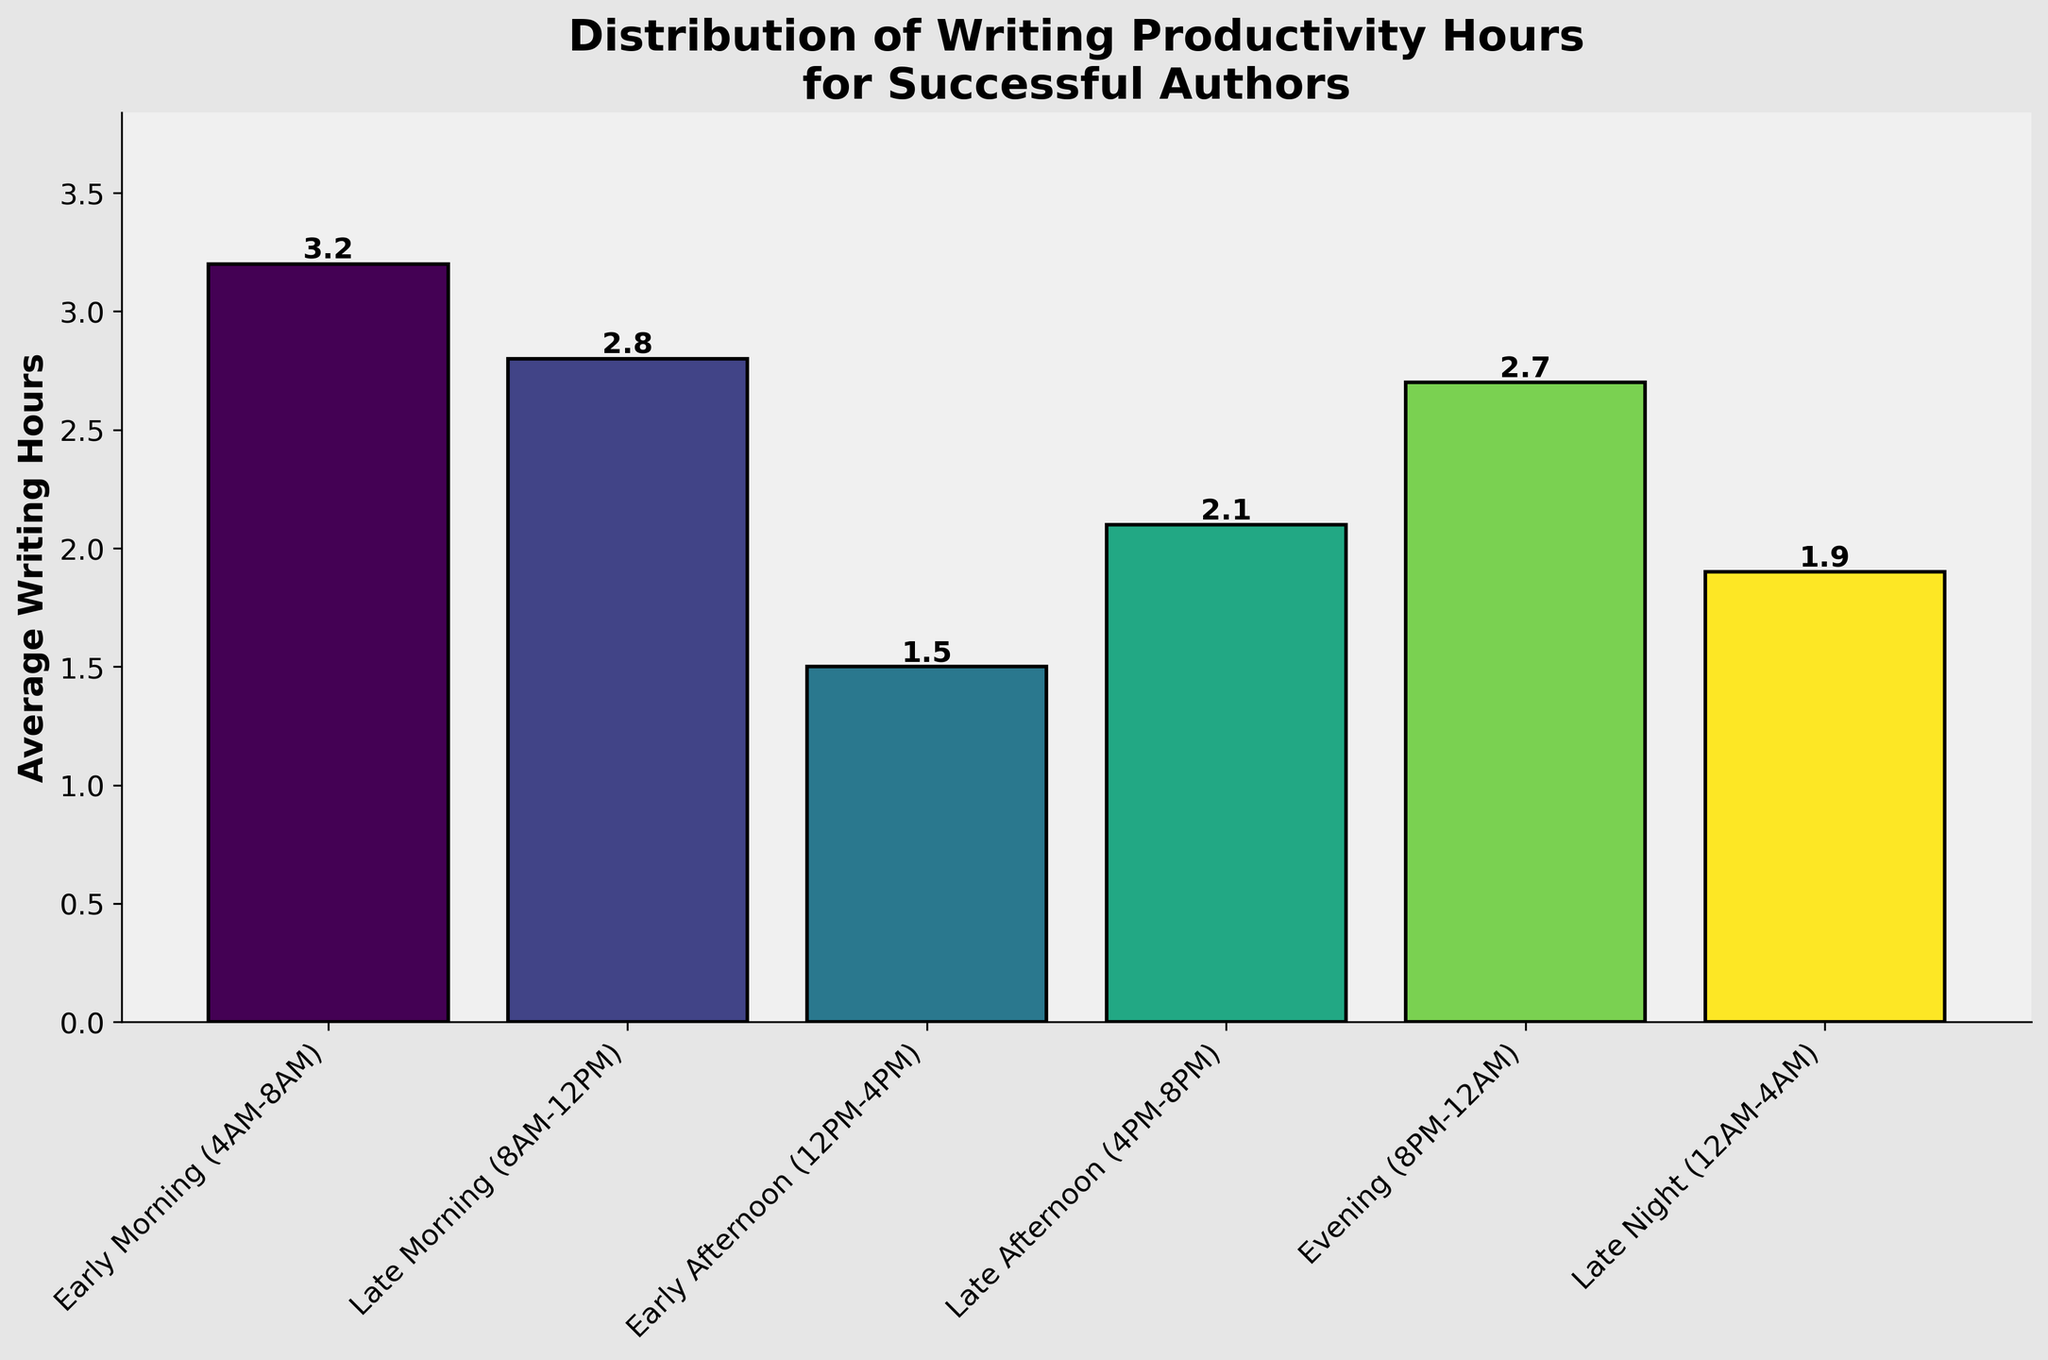What time of day has the highest average writing hours? The highest bar visually represents the time with the highest average writing hours. By looking at the plot, Early Morning (4AM-8AM) has the tallest bar, indicating the highest average.
Answer: Early Morning (4AM-8AM) Which time of day has a smaller average writing hours: Late Morning or Evening? By comparing the heights of the bars for Late Morning (8AM-12PM) and Evening (8PM-12AM), Late Morning has 2.8 hours, and Evening has 2.7 hours. Late Morning has a slightly larger average.
Answer: Evening (8PM-12AM) What is the total average writing hours for authors from Early Afternoon to Late Night combined? Sum the average writing hours of the periods from Early Afternoon (12PM-4PM), Late Afternoon (4PM-8PM), Evening (8PM-12AM), and Late Night (12AM-4AM). The totals are: 1.5 + 2.1 + 2.7 + 1.9 = 8.2 hours.
Answer: 8.2 If you only considered writing hours from 4AM to 8PM, what would be the average of those hours? Sum the hours for Early Morning (4AM-8AM), Late Morning (8AM-12PM), Early Afternoon (12PM-4PM), and Late Afternoon (4PM-8PM), then divide by the number of periods. The calculation is: (3.2 + 2.8 + 1.5 + 2.1) / 4 = 2.4 average hours.
Answer: 2.4 What is the difference in average writing hours between Early Morning and Early Afternoon? Subtract the average writing hours of Early Afternoon (1.5) from Early Morning (3.2). The difference is 3.2 - 1.5 = 1.7 hours.
Answer: 1.7 Which time period shows similar average writing hours: Early Morning and Late Morning or Late Afternoon and Late Night? Compare heights: Early Morning (3.2) and Late Morning (2.8) have a difference of 0.4 hours. Late Afternoon (2.1) and Late Night (1.9) have a difference of 0.2 hours. Late Afternoon and Late Night are more similar.
Answer: Late Afternoon and Late Night Is there any time period that has more average writing hours than both Evening and Late Night? Check if any bar is higher than both the Evening (2.7) and Late Night (1.9) bars. Early Morning (3.2) and Late Morning (2.8) are both higher.
Answer: Early Morning and Late Morning During which time of day is writing productivity lowest for successful authors? The shortest bar represents the lowest productivity. Early Afternoon (12PM-4PM) shows the shortest bar with 1.5 hours.
Answer: Early Afternoon (12PM-4PM) How much more time do successful authors spend writing in Late Morning compared to Late Afternoon? Subtract the average writing hours of Late Afternoon (2.1) from Late Morning (2.8). The difference is 2.8 - 2.1 = 0.7 hours.
Answer: 0.7 Combine the productivity of Early Morning and Late Night, which time period has a combined average writing hours close to this sum? Sum the hours for Early Morning (3.2) and Late Night (1.9) to get 5.1. Compare this sum with other combinations to find the closest. Late Morning (2.8) + Late Afternoon (2.1) = 4.9, which is the closest.
Answer: Late Morning and Late Afternoon 